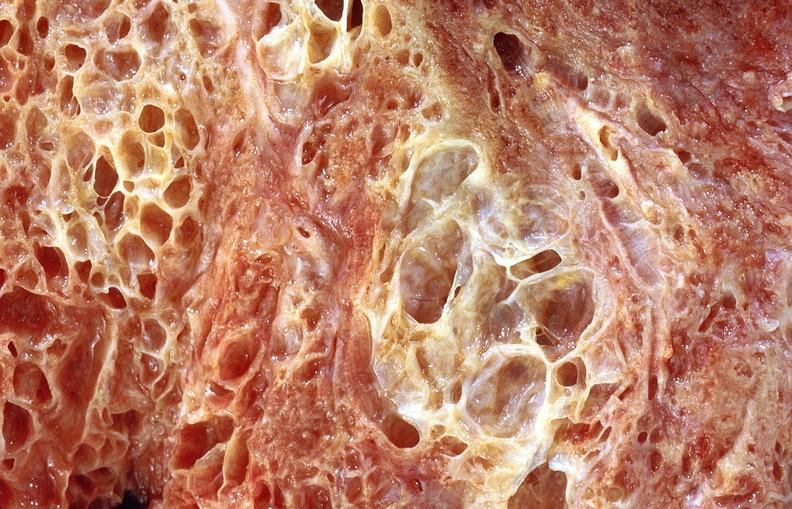s respiratory present?
Answer the question using a single word or phrase. Yes 